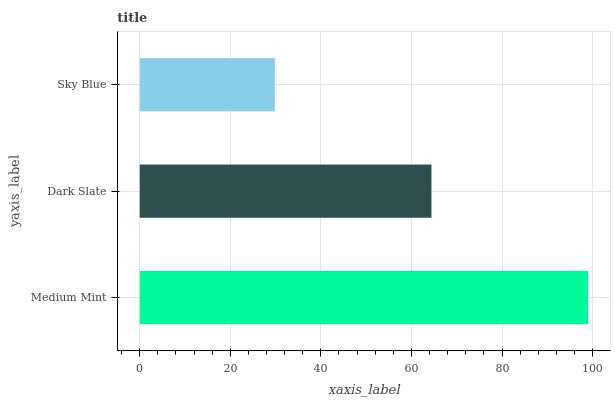Is Sky Blue the minimum?
Answer yes or no. Yes. Is Medium Mint the maximum?
Answer yes or no. Yes. Is Dark Slate the minimum?
Answer yes or no. No. Is Dark Slate the maximum?
Answer yes or no. No. Is Medium Mint greater than Dark Slate?
Answer yes or no. Yes. Is Dark Slate less than Medium Mint?
Answer yes or no. Yes. Is Dark Slate greater than Medium Mint?
Answer yes or no. No. Is Medium Mint less than Dark Slate?
Answer yes or no. No. Is Dark Slate the high median?
Answer yes or no. Yes. Is Dark Slate the low median?
Answer yes or no. Yes. Is Sky Blue the high median?
Answer yes or no. No. Is Medium Mint the low median?
Answer yes or no. No. 